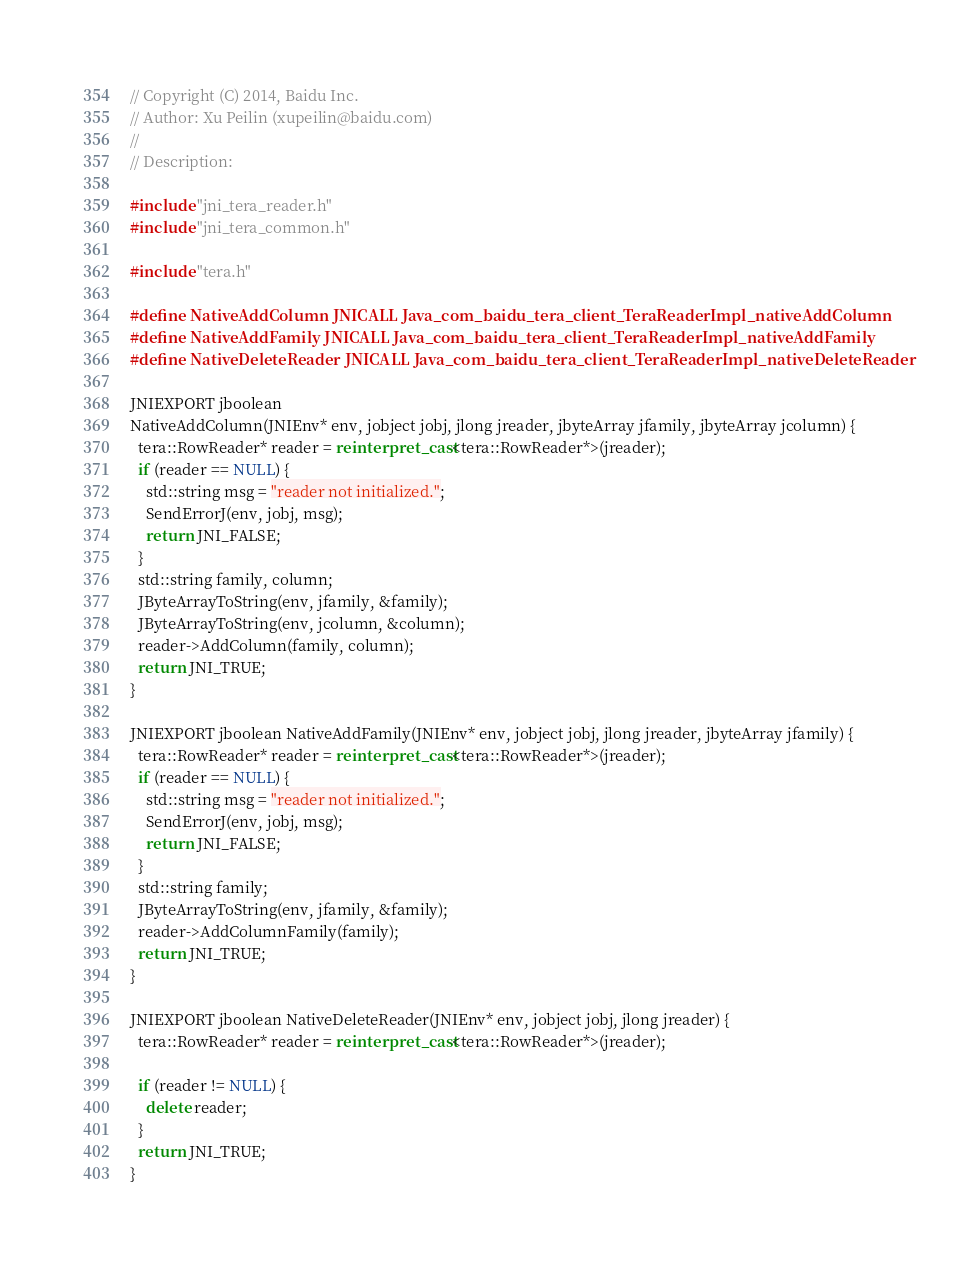<code> <loc_0><loc_0><loc_500><loc_500><_C++_>// Copyright (C) 2014, Baidu Inc.
// Author: Xu Peilin (xupeilin@baidu.com)
//
// Description:

#include "jni_tera_reader.h"
#include "jni_tera_common.h"

#include "tera.h"

#define NativeAddColumn JNICALL Java_com_baidu_tera_client_TeraReaderImpl_nativeAddColumn
#define NativeAddFamily JNICALL Java_com_baidu_tera_client_TeraReaderImpl_nativeAddFamily
#define NativeDeleteReader JNICALL Java_com_baidu_tera_client_TeraReaderImpl_nativeDeleteReader

JNIEXPORT jboolean
NativeAddColumn(JNIEnv* env, jobject jobj, jlong jreader, jbyteArray jfamily, jbyteArray jcolumn) {
  tera::RowReader* reader = reinterpret_cast<tera::RowReader*>(jreader);
  if (reader == NULL) {
    std::string msg = "reader not initialized.";
    SendErrorJ(env, jobj, msg);
    return JNI_FALSE;
  }
  std::string family, column;
  JByteArrayToString(env, jfamily, &family);
  JByteArrayToString(env, jcolumn, &column);
  reader->AddColumn(family, column);
  return JNI_TRUE;
}

JNIEXPORT jboolean NativeAddFamily(JNIEnv* env, jobject jobj, jlong jreader, jbyteArray jfamily) {
  tera::RowReader* reader = reinterpret_cast<tera::RowReader*>(jreader);
  if (reader == NULL) {
    std::string msg = "reader not initialized.";
    SendErrorJ(env, jobj, msg);
    return JNI_FALSE;
  }
  std::string family;
  JByteArrayToString(env, jfamily, &family);
  reader->AddColumnFamily(family);
  return JNI_TRUE;
}

JNIEXPORT jboolean NativeDeleteReader(JNIEnv* env, jobject jobj, jlong jreader) {
  tera::RowReader* reader = reinterpret_cast<tera::RowReader*>(jreader);

  if (reader != NULL) {
    delete reader;
  }
  return JNI_TRUE;
}
</code> 